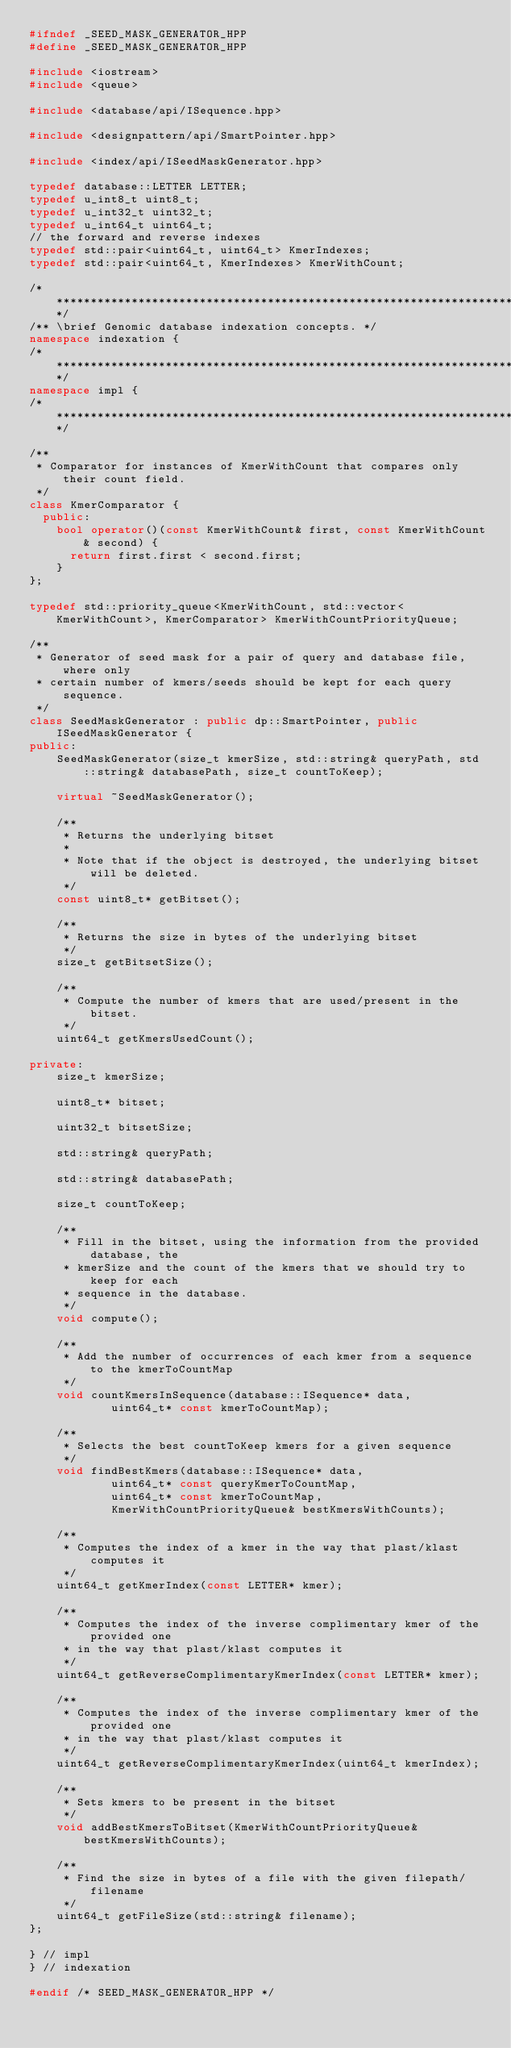<code> <loc_0><loc_0><loc_500><loc_500><_C++_>#ifndef _SEED_MASK_GENERATOR_HPP
#define _SEED_MASK_GENERATOR_HPP

#include <iostream>
#include <queue>

#include <database/api/ISequence.hpp>

#include <designpattern/api/SmartPointer.hpp>

#include <index/api/ISeedMaskGenerator.hpp>

typedef database::LETTER LETTER;
typedef u_int8_t uint8_t;
typedef u_int32_t uint32_t;
typedef u_int64_t uint64_t;
// the forward and reverse indexes
typedef std::pair<uint64_t, uint64_t> KmerIndexes;
typedef std::pair<uint64_t, KmerIndexes> KmerWithCount;

/********************************************************************************/
/** \brief Genomic database indexation concepts. */
namespace indexation {
/********************************************************************************/
namespace impl {
/********************************************************************************/

/**
 * Comparator for instances of KmerWithCount that compares only their count field.
 */
class KmerComparator {
  public:
    bool operator()(const KmerWithCount& first, const KmerWithCount& second) {
      return first.first < second.first;
    }
};

typedef std::priority_queue<KmerWithCount, std::vector<KmerWithCount>, KmerComparator> KmerWithCountPriorityQueue;

/**
 * Generator of seed mask for a pair of query and database file, where only
 * certain number of kmers/seeds should be kept for each query sequence.
 */
class SeedMaskGenerator : public dp::SmartPointer, public ISeedMaskGenerator {
public:
    SeedMaskGenerator(size_t kmerSize, std::string& queryPath, std::string& databasePath, size_t countToKeep);

    virtual ~SeedMaskGenerator();

    /**
     * Returns the underlying bitset
     *
     * Note that if the object is destroyed, the underlying bitset will be deleted.
     */
    const uint8_t* getBitset();

    /**
     * Returns the size in bytes of the underlying bitset
     */
    size_t getBitsetSize();

    /**
     * Compute the number of kmers that are used/present in the bitset.
     */
    uint64_t getKmersUsedCount();

private:
    size_t kmerSize;

    uint8_t* bitset;

    uint32_t bitsetSize;

    std::string& queryPath;

    std::string& databasePath;

    size_t countToKeep;

    /**
     * Fill in the bitset, using the information from the provided database, the
     * kmerSize and the count of the kmers that we should try to keep for each
     * sequence in the database.
     */
    void compute();

    /**
     * Add the number of occurrences of each kmer from a sequence to the kmerToCountMap
     */
    void countKmersInSequence(database::ISequence* data,
            uint64_t* const kmerToCountMap);

    /**
     * Selects the best countToKeep kmers for a given sequence
     */
    void findBestKmers(database::ISequence* data,
            uint64_t* const queryKmerToCountMap,
            uint64_t* const kmerToCountMap,
            KmerWithCountPriorityQueue& bestKmersWithCounts);

    /**
     * Computes the index of a kmer in the way that plast/klast computes it
     */
    uint64_t getKmerIndex(const LETTER* kmer);

    /**
     * Computes the index of the inverse complimentary kmer of the provided one
     * in the way that plast/klast computes it
     */
    uint64_t getReverseComplimentaryKmerIndex(const LETTER* kmer);

    /**
     * Computes the index of the inverse complimentary kmer of the provided one
     * in the way that plast/klast computes it
     */
    uint64_t getReverseComplimentaryKmerIndex(uint64_t kmerIndex);

    /**
     * Sets kmers to be present in the bitset
     */
    void addBestKmersToBitset(KmerWithCountPriorityQueue& bestKmersWithCounts);

    /**
     * Find the size in bytes of a file with the given filepath/filename
     */
    uint64_t getFileSize(std::string& filename);
};

} // impl
} // indexation

#endif /* SEED_MASK_GENERATOR_HPP */
</code> 